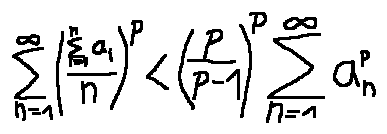Convert formula to latex. <formula><loc_0><loc_0><loc_500><loc_500>\sum \lim i t s _ { n = 1 } ^ { \infty } ( \frac { \sum \lim i t s _ { i = 1 } ^ { n } a _ { i } } { n } ) ^ { p } < ( \frac { p } { p - 1 } ) ^ { p } \sum \lim i t s _ { n = 1 } ^ { \infty } a _ { n } ^ { p }</formula> 